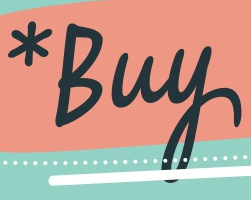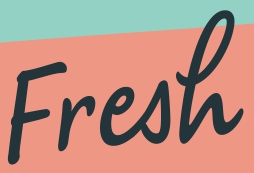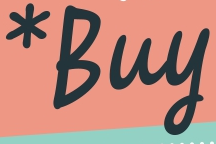Read the text from these images in sequence, separated by a semicolon. *Buy; Fresh; *Buy 